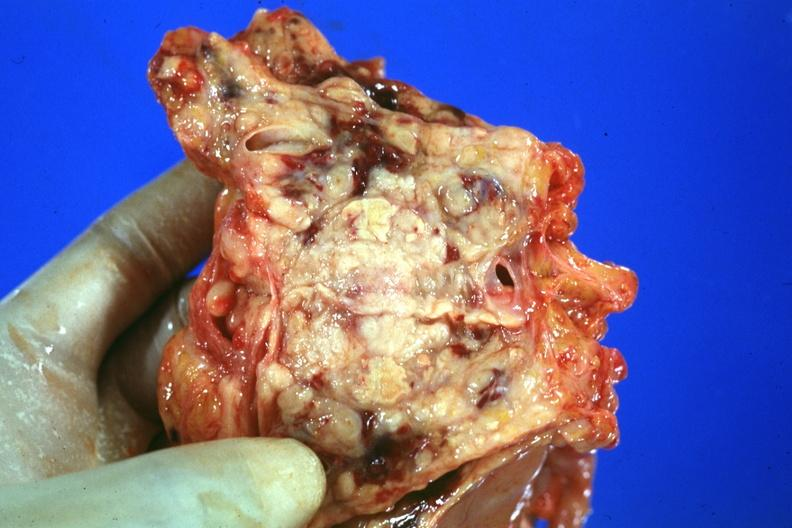what is cut open showing neoplasm quite good?
Answer the question using a single word or phrase. Prostate 